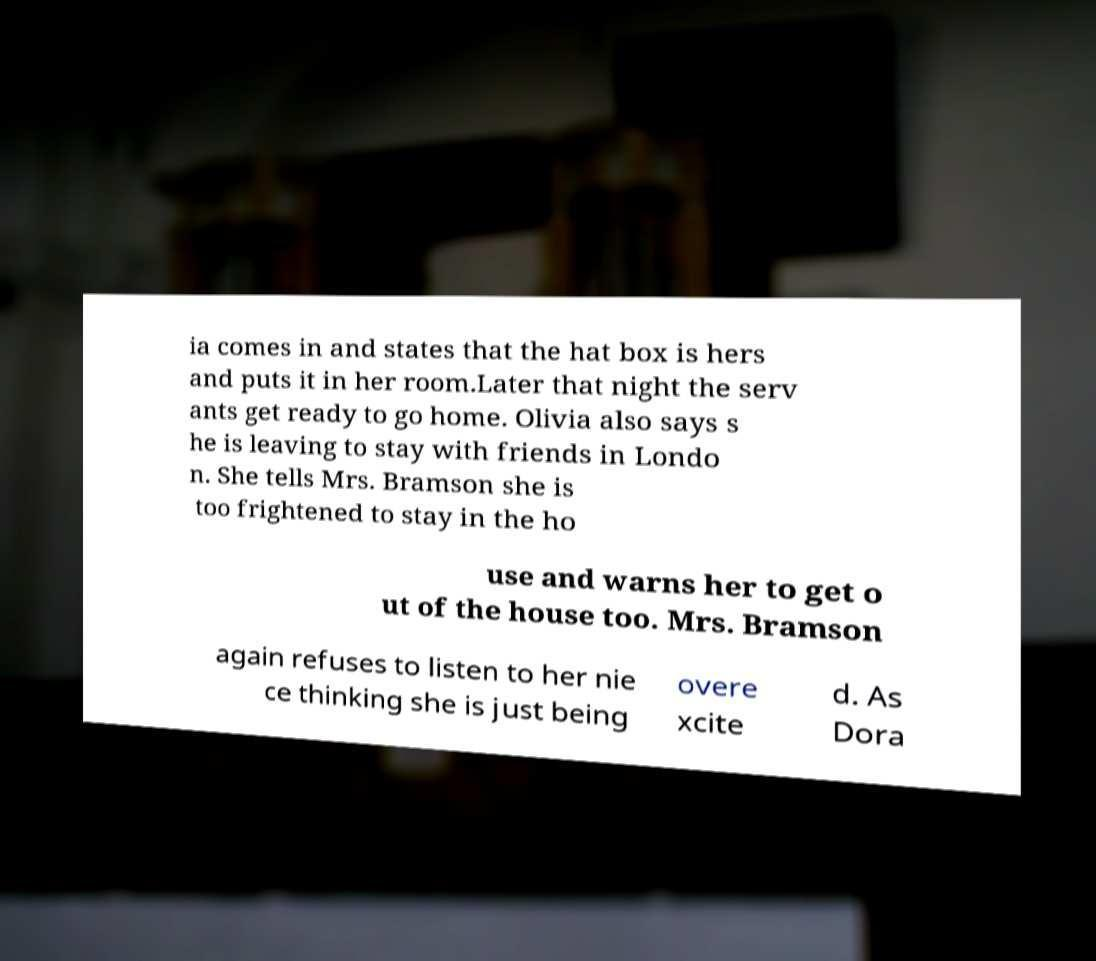There's text embedded in this image that I need extracted. Can you transcribe it verbatim? ia comes in and states that the hat box is hers and puts it in her room.Later that night the serv ants get ready to go home. Olivia also says s he is leaving to stay with friends in Londo n. She tells Mrs. Bramson she is too frightened to stay in the ho use and warns her to get o ut of the house too. Mrs. Bramson again refuses to listen to her nie ce thinking she is just being overe xcite d. As Dora 